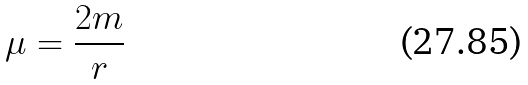<formula> <loc_0><loc_0><loc_500><loc_500>\mu = \frac { 2 m } r</formula> 